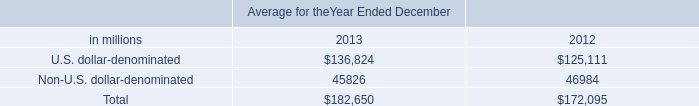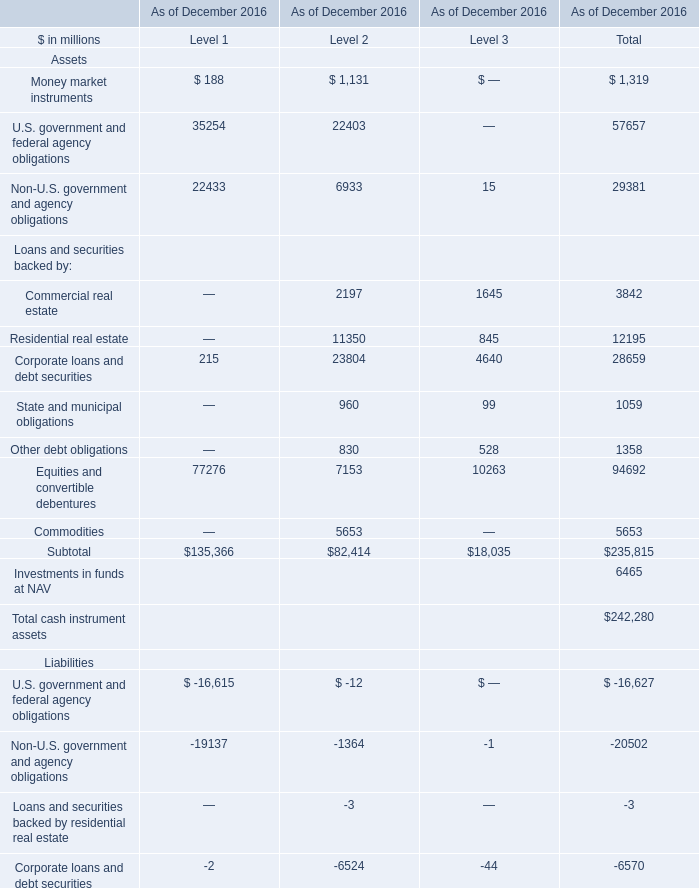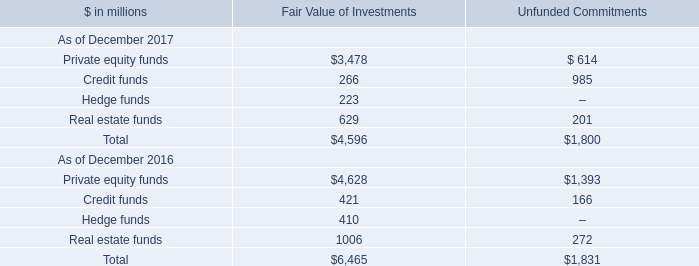In the year with largest amount of Private equity funds of Fair Value of Investments in Table 2, what's the sum of Commercial real estate in Table 1? (in million) 
Computations: (2197 + 1645)
Answer: 3842.0. 